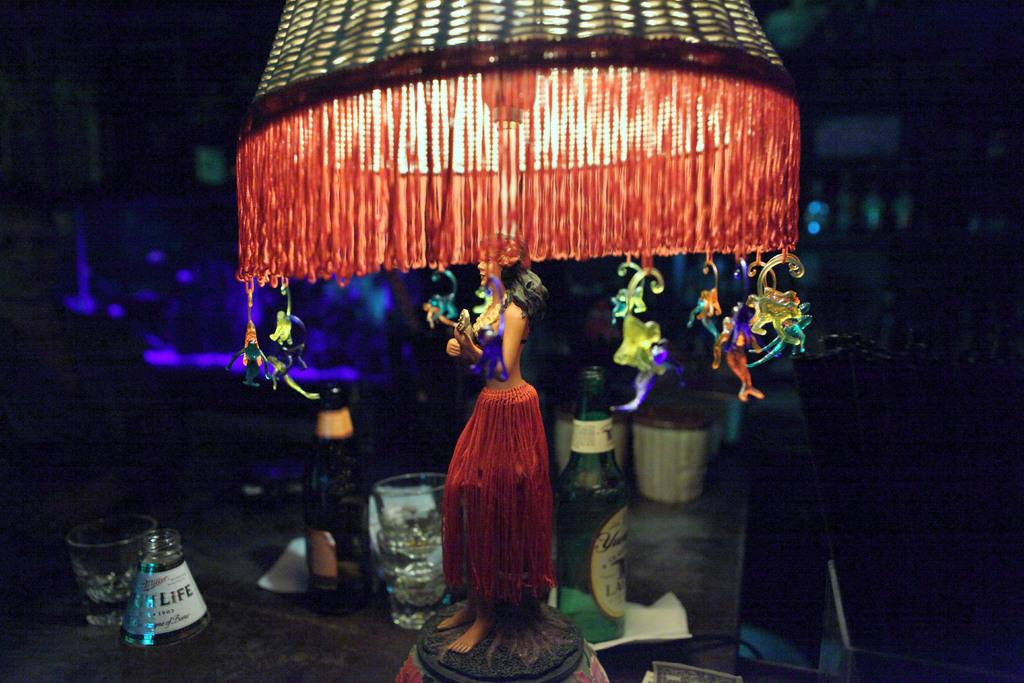What is the source of light in the image? There is a light in the image. What piece of furniture is present in the image? There is a table in the image. What items can be seen on the table? There are glasses, bottles, and a doll on the table. What color is the square on the knee of the passenger in the image? There is no square, knee, or passenger present in the image. 